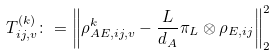<formula> <loc_0><loc_0><loc_500><loc_500>T _ { i j , v } ^ { ( k ) } \colon = \left \| \rho _ { A E , i j , v } ^ { k } - \frac { L } { d _ { A } } \pi _ { L } \otimes \rho _ { E , i j } \right \| _ { 2 } ^ { 2 }</formula> 